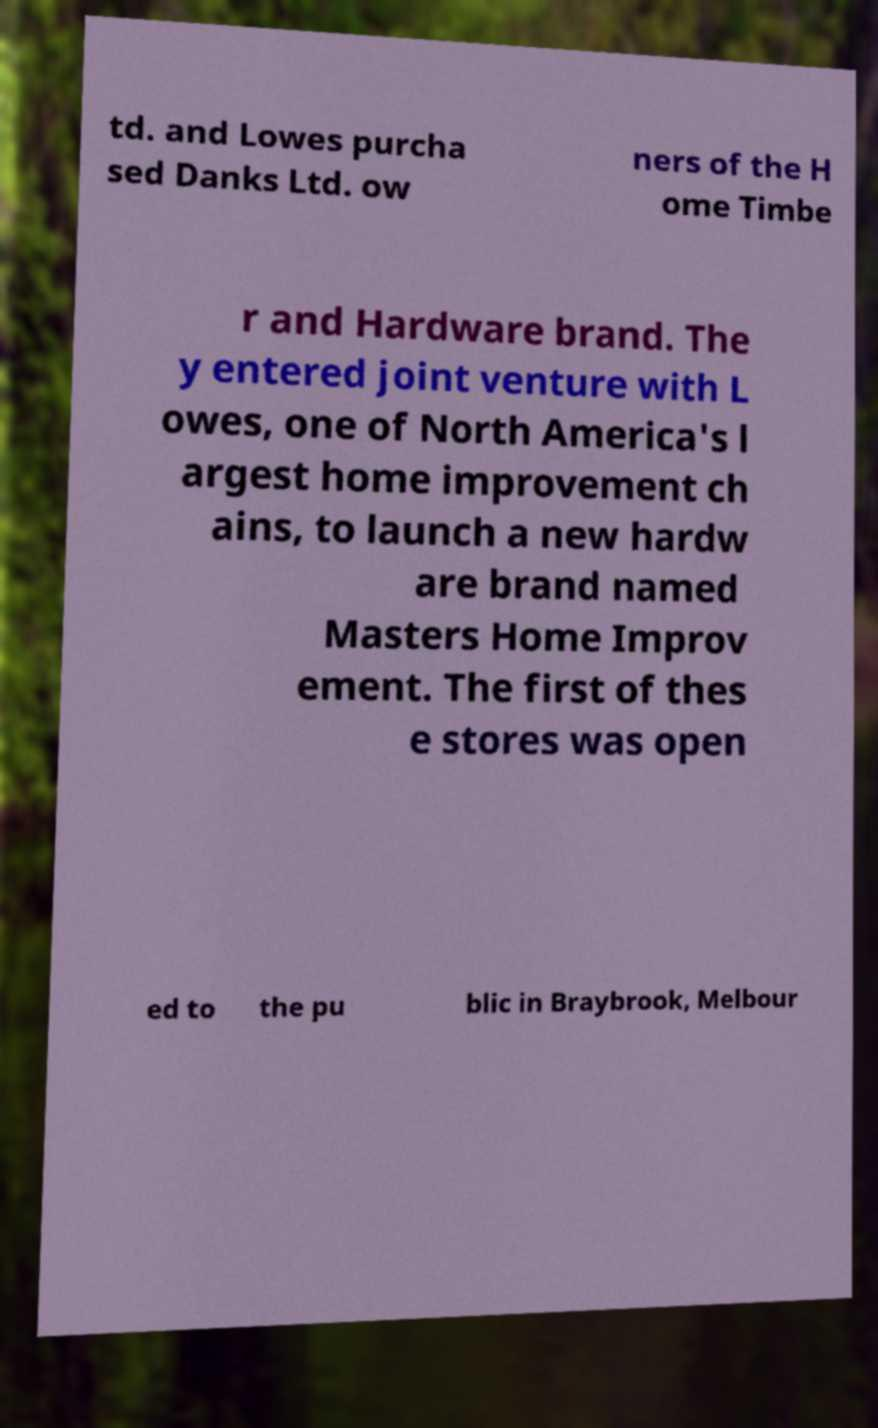For documentation purposes, I need the text within this image transcribed. Could you provide that? td. and Lowes purcha sed Danks Ltd. ow ners of the H ome Timbe r and Hardware brand. The y entered joint venture with L owes, one of North America's l argest home improvement ch ains, to launch a new hardw are brand named Masters Home Improv ement. The first of thes e stores was open ed to the pu blic in Braybrook, Melbour 